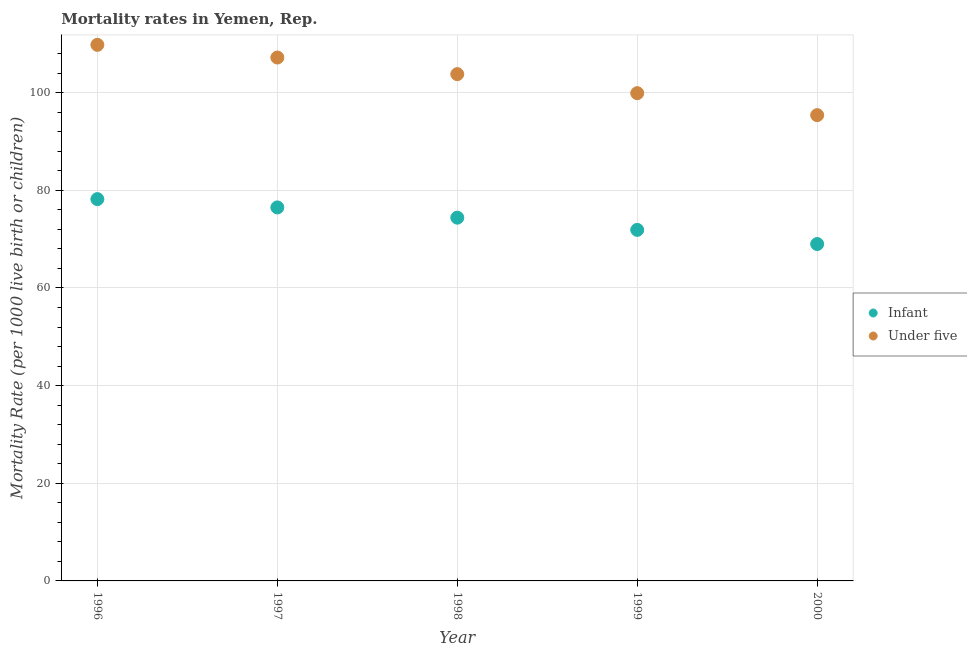How many different coloured dotlines are there?
Your response must be concise. 2. Is the number of dotlines equal to the number of legend labels?
Offer a very short reply. Yes. What is the under-5 mortality rate in 1999?
Your answer should be very brief. 99.9. Across all years, what is the maximum infant mortality rate?
Give a very brief answer. 78.2. Across all years, what is the minimum under-5 mortality rate?
Offer a very short reply. 95.4. In which year was the under-5 mortality rate maximum?
Offer a very short reply. 1996. In which year was the under-5 mortality rate minimum?
Make the answer very short. 2000. What is the total infant mortality rate in the graph?
Offer a terse response. 370. What is the difference between the infant mortality rate in 1996 and that in 2000?
Your answer should be very brief. 9.2. What is the difference between the under-5 mortality rate in 2000 and the infant mortality rate in 1998?
Give a very brief answer. 21. What is the average infant mortality rate per year?
Your response must be concise. 74. In the year 1997, what is the difference between the infant mortality rate and under-5 mortality rate?
Give a very brief answer. -30.7. What is the ratio of the under-5 mortality rate in 1998 to that in 2000?
Your answer should be very brief. 1.09. Is the infant mortality rate in 1996 less than that in 1999?
Give a very brief answer. No. Is the difference between the infant mortality rate in 1997 and 1999 greater than the difference between the under-5 mortality rate in 1997 and 1999?
Offer a terse response. No. What is the difference between the highest and the second highest infant mortality rate?
Your response must be concise. 1.7. What is the difference between the highest and the lowest infant mortality rate?
Provide a succinct answer. 9.2. In how many years, is the infant mortality rate greater than the average infant mortality rate taken over all years?
Provide a short and direct response. 3. Is the infant mortality rate strictly less than the under-5 mortality rate over the years?
Provide a succinct answer. Yes. How many years are there in the graph?
Ensure brevity in your answer.  5. Where does the legend appear in the graph?
Your response must be concise. Center right. What is the title of the graph?
Offer a very short reply. Mortality rates in Yemen, Rep. Does "Birth rate" appear as one of the legend labels in the graph?
Your answer should be compact. No. What is the label or title of the Y-axis?
Your answer should be compact. Mortality Rate (per 1000 live birth or children). What is the Mortality Rate (per 1000 live birth or children) of Infant in 1996?
Give a very brief answer. 78.2. What is the Mortality Rate (per 1000 live birth or children) in Under five in 1996?
Provide a short and direct response. 109.8. What is the Mortality Rate (per 1000 live birth or children) in Infant in 1997?
Make the answer very short. 76.5. What is the Mortality Rate (per 1000 live birth or children) of Under five in 1997?
Your response must be concise. 107.2. What is the Mortality Rate (per 1000 live birth or children) in Infant in 1998?
Provide a succinct answer. 74.4. What is the Mortality Rate (per 1000 live birth or children) in Under five in 1998?
Your response must be concise. 103.8. What is the Mortality Rate (per 1000 live birth or children) of Infant in 1999?
Ensure brevity in your answer.  71.9. What is the Mortality Rate (per 1000 live birth or children) of Under five in 1999?
Give a very brief answer. 99.9. What is the Mortality Rate (per 1000 live birth or children) in Under five in 2000?
Your answer should be very brief. 95.4. Across all years, what is the maximum Mortality Rate (per 1000 live birth or children) in Infant?
Your response must be concise. 78.2. Across all years, what is the maximum Mortality Rate (per 1000 live birth or children) in Under five?
Provide a short and direct response. 109.8. Across all years, what is the minimum Mortality Rate (per 1000 live birth or children) in Infant?
Offer a very short reply. 69. Across all years, what is the minimum Mortality Rate (per 1000 live birth or children) in Under five?
Your answer should be compact. 95.4. What is the total Mortality Rate (per 1000 live birth or children) of Infant in the graph?
Ensure brevity in your answer.  370. What is the total Mortality Rate (per 1000 live birth or children) in Under five in the graph?
Your answer should be very brief. 516.1. What is the difference between the Mortality Rate (per 1000 live birth or children) in Under five in 1996 and that in 1998?
Offer a very short reply. 6. What is the difference between the Mortality Rate (per 1000 live birth or children) in Under five in 1996 and that in 1999?
Ensure brevity in your answer.  9.9. What is the difference between the Mortality Rate (per 1000 live birth or children) of Infant in 1997 and that in 1998?
Offer a terse response. 2.1. What is the difference between the Mortality Rate (per 1000 live birth or children) of Under five in 1997 and that in 1999?
Your answer should be very brief. 7.3. What is the difference between the Mortality Rate (per 1000 live birth or children) of Infant in 1998 and that in 1999?
Offer a terse response. 2.5. What is the difference between the Mortality Rate (per 1000 live birth or children) of Infant in 1998 and that in 2000?
Keep it short and to the point. 5.4. What is the difference between the Mortality Rate (per 1000 live birth or children) in Under five in 1998 and that in 2000?
Provide a succinct answer. 8.4. What is the difference between the Mortality Rate (per 1000 live birth or children) in Infant in 1999 and that in 2000?
Ensure brevity in your answer.  2.9. What is the difference between the Mortality Rate (per 1000 live birth or children) in Under five in 1999 and that in 2000?
Keep it short and to the point. 4.5. What is the difference between the Mortality Rate (per 1000 live birth or children) in Infant in 1996 and the Mortality Rate (per 1000 live birth or children) in Under five in 1998?
Offer a terse response. -25.6. What is the difference between the Mortality Rate (per 1000 live birth or children) in Infant in 1996 and the Mortality Rate (per 1000 live birth or children) in Under five in 1999?
Provide a succinct answer. -21.7. What is the difference between the Mortality Rate (per 1000 live birth or children) of Infant in 1996 and the Mortality Rate (per 1000 live birth or children) of Under five in 2000?
Offer a terse response. -17.2. What is the difference between the Mortality Rate (per 1000 live birth or children) in Infant in 1997 and the Mortality Rate (per 1000 live birth or children) in Under five in 1998?
Provide a succinct answer. -27.3. What is the difference between the Mortality Rate (per 1000 live birth or children) in Infant in 1997 and the Mortality Rate (per 1000 live birth or children) in Under five in 1999?
Offer a terse response. -23.4. What is the difference between the Mortality Rate (per 1000 live birth or children) in Infant in 1997 and the Mortality Rate (per 1000 live birth or children) in Under five in 2000?
Your response must be concise. -18.9. What is the difference between the Mortality Rate (per 1000 live birth or children) in Infant in 1998 and the Mortality Rate (per 1000 live birth or children) in Under five in 1999?
Provide a short and direct response. -25.5. What is the difference between the Mortality Rate (per 1000 live birth or children) in Infant in 1998 and the Mortality Rate (per 1000 live birth or children) in Under five in 2000?
Ensure brevity in your answer.  -21. What is the difference between the Mortality Rate (per 1000 live birth or children) of Infant in 1999 and the Mortality Rate (per 1000 live birth or children) of Under five in 2000?
Keep it short and to the point. -23.5. What is the average Mortality Rate (per 1000 live birth or children) of Under five per year?
Your answer should be very brief. 103.22. In the year 1996, what is the difference between the Mortality Rate (per 1000 live birth or children) in Infant and Mortality Rate (per 1000 live birth or children) in Under five?
Your answer should be compact. -31.6. In the year 1997, what is the difference between the Mortality Rate (per 1000 live birth or children) of Infant and Mortality Rate (per 1000 live birth or children) of Under five?
Offer a very short reply. -30.7. In the year 1998, what is the difference between the Mortality Rate (per 1000 live birth or children) in Infant and Mortality Rate (per 1000 live birth or children) in Under five?
Provide a short and direct response. -29.4. In the year 2000, what is the difference between the Mortality Rate (per 1000 live birth or children) in Infant and Mortality Rate (per 1000 live birth or children) in Under five?
Offer a terse response. -26.4. What is the ratio of the Mortality Rate (per 1000 live birth or children) in Infant in 1996 to that in 1997?
Make the answer very short. 1.02. What is the ratio of the Mortality Rate (per 1000 live birth or children) in Under five in 1996 to that in 1997?
Provide a succinct answer. 1.02. What is the ratio of the Mortality Rate (per 1000 live birth or children) of Infant in 1996 to that in 1998?
Offer a very short reply. 1.05. What is the ratio of the Mortality Rate (per 1000 live birth or children) in Under five in 1996 to that in 1998?
Make the answer very short. 1.06. What is the ratio of the Mortality Rate (per 1000 live birth or children) of Infant in 1996 to that in 1999?
Offer a terse response. 1.09. What is the ratio of the Mortality Rate (per 1000 live birth or children) of Under five in 1996 to that in 1999?
Give a very brief answer. 1.1. What is the ratio of the Mortality Rate (per 1000 live birth or children) in Infant in 1996 to that in 2000?
Provide a succinct answer. 1.13. What is the ratio of the Mortality Rate (per 1000 live birth or children) in Under five in 1996 to that in 2000?
Keep it short and to the point. 1.15. What is the ratio of the Mortality Rate (per 1000 live birth or children) of Infant in 1997 to that in 1998?
Keep it short and to the point. 1.03. What is the ratio of the Mortality Rate (per 1000 live birth or children) of Under five in 1997 to that in 1998?
Your answer should be compact. 1.03. What is the ratio of the Mortality Rate (per 1000 live birth or children) of Infant in 1997 to that in 1999?
Provide a succinct answer. 1.06. What is the ratio of the Mortality Rate (per 1000 live birth or children) in Under five in 1997 to that in 1999?
Provide a short and direct response. 1.07. What is the ratio of the Mortality Rate (per 1000 live birth or children) in Infant in 1997 to that in 2000?
Your answer should be very brief. 1.11. What is the ratio of the Mortality Rate (per 1000 live birth or children) in Under five in 1997 to that in 2000?
Your answer should be very brief. 1.12. What is the ratio of the Mortality Rate (per 1000 live birth or children) of Infant in 1998 to that in 1999?
Your answer should be compact. 1.03. What is the ratio of the Mortality Rate (per 1000 live birth or children) of Under five in 1998 to that in 1999?
Give a very brief answer. 1.04. What is the ratio of the Mortality Rate (per 1000 live birth or children) of Infant in 1998 to that in 2000?
Your answer should be compact. 1.08. What is the ratio of the Mortality Rate (per 1000 live birth or children) of Under five in 1998 to that in 2000?
Ensure brevity in your answer.  1.09. What is the ratio of the Mortality Rate (per 1000 live birth or children) in Infant in 1999 to that in 2000?
Make the answer very short. 1.04. What is the ratio of the Mortality Rate (per 1000 live birth or children) in Under five in 1999 to that in 2000?
Give a very brief answer. 1.05. What is the difference between the highest and the second highest Mortality Rate (per 1000 live birth or children) of Infant?
Provide a succinct answer. 1.7. 